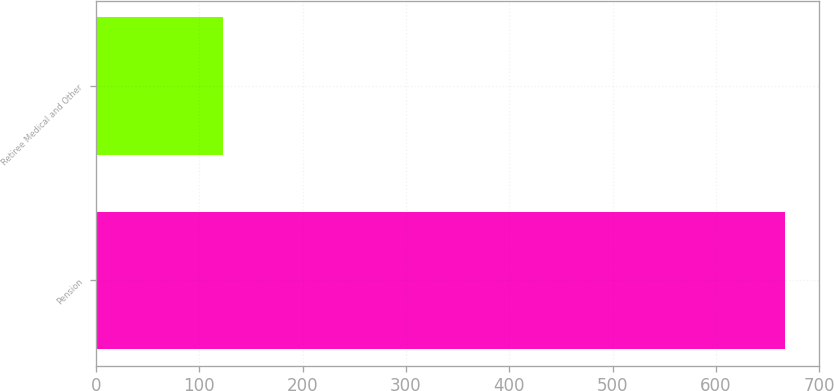Convert chart to OTSL. <chart><loc_0><loc_0><loc_500><loc_500><bar_chart><fcel>Pension<fcel>Retiree Medical and Other<nl><fcel>667<fcel>123<nl></chart> 